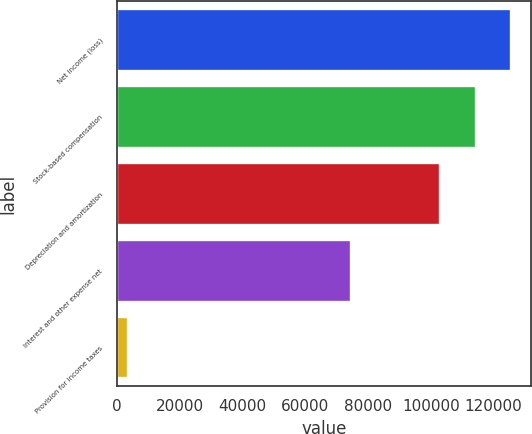Convert chart. <chart><loc_0><loc_0><loc_500><loc_500><bar_chart><fcel>Net income (loss)<fcel>Stock-based compensation<fcel>Depreciation and amortization<fcel>Interest and other expense net<fcel>Provision for income taxes<nl><fcel>125678<fcel>114370<fcel>103063<fcel>74716<fcel>3413<nl></chart> 